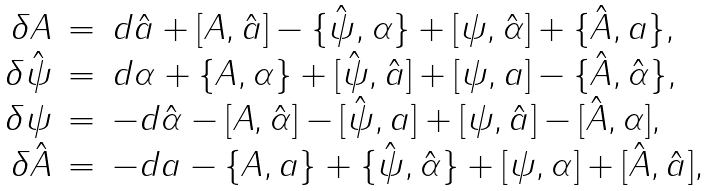Convert formula to latex. <formula><loc_0><loc_0><loc_500><loc_500>\begin{array} { r c l } \delta A & = & d \hat { a } + [ A , \hat { a } ] - \{ \hat { \psi } , \alpha \} + [ \psi , \hat { \alpha } ] + \{ \hat { A } , a \} , \\ \delta \hat { \psi } & = & d \alpha + \{ A , \alpha \} + [ \hat { \psi } , \hat { a } ] + [ \psi , a ] - \{ \hat { A } , \hat { \alpha } \} , \\ \delta \psi & = & - d \hat { \alpha } - [ A , \hat { \alpha } ] - [ \hat { \psi } , a ] + [ \psi , \hat { a } ] - [ \hat { A } , \alpha ] , \\ \delta \hat { A } & = & - d a - \{ A , a \} + \{ \hat { \psi } , \hat { \alpha } \} + [ \psi , \alpha ] + [ \hat { A } , \hat { a } ] , \end{array}</formula> 